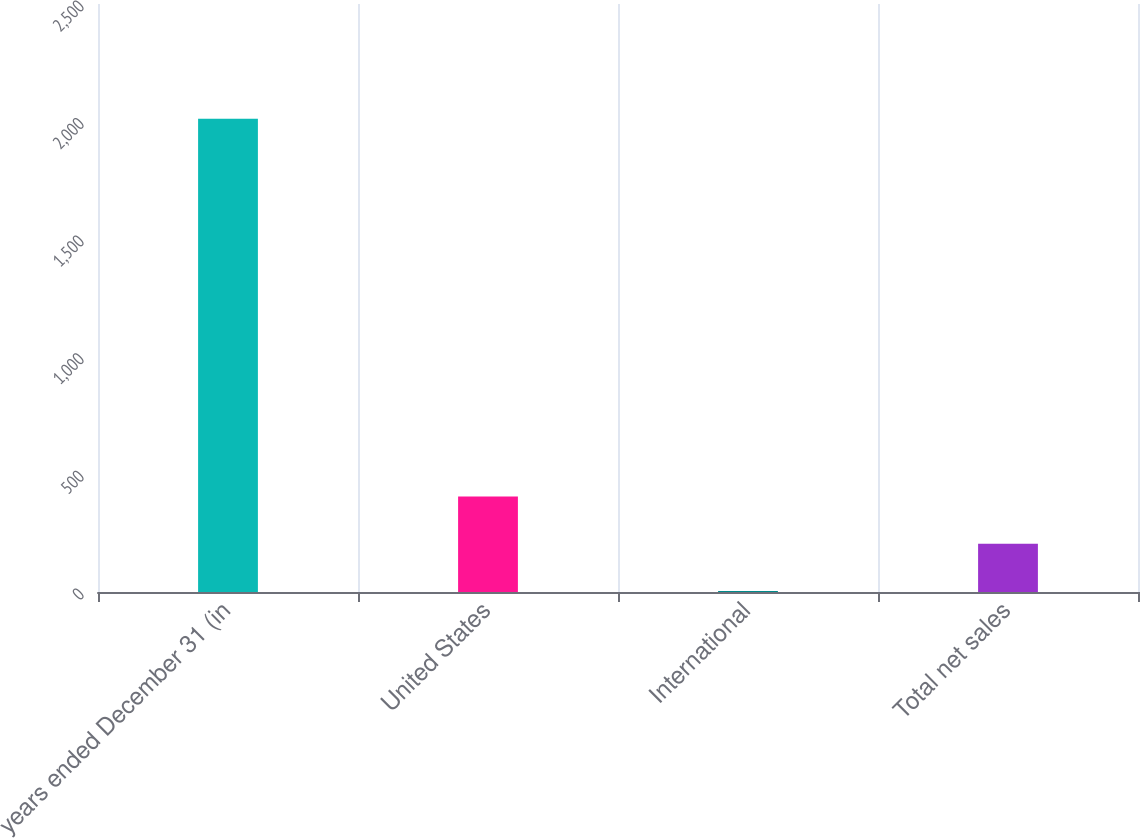<chart> <loc_0><loc_0><loc_500><loc_500><bar_chart><fcel>years ended December 31 (in<fcel>United States<fcel>International<fcel>Total net sales<nl><fcel>2012<fcel>405.6<fcel>4<fcel>204.8<nl></chart> 